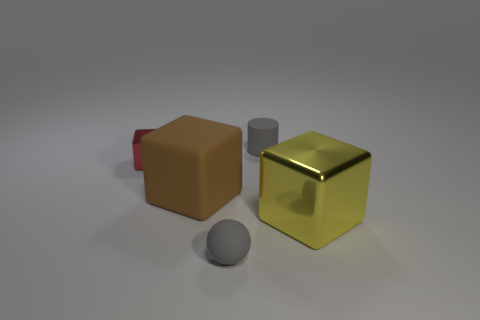Add 2 red metallic objects. How many objects exist? 7 Subtract all cubes. How many objects are left? 2 Subtract 1 red blocks. How many objects are left? 4 Subtract all cylinders. Subtract all brown blocks. How many objects are left? 3 Add 3 big brown objects. How many big brown objects are left? 4 Add 3 large brown objects. How many large brown objects exist? 4 